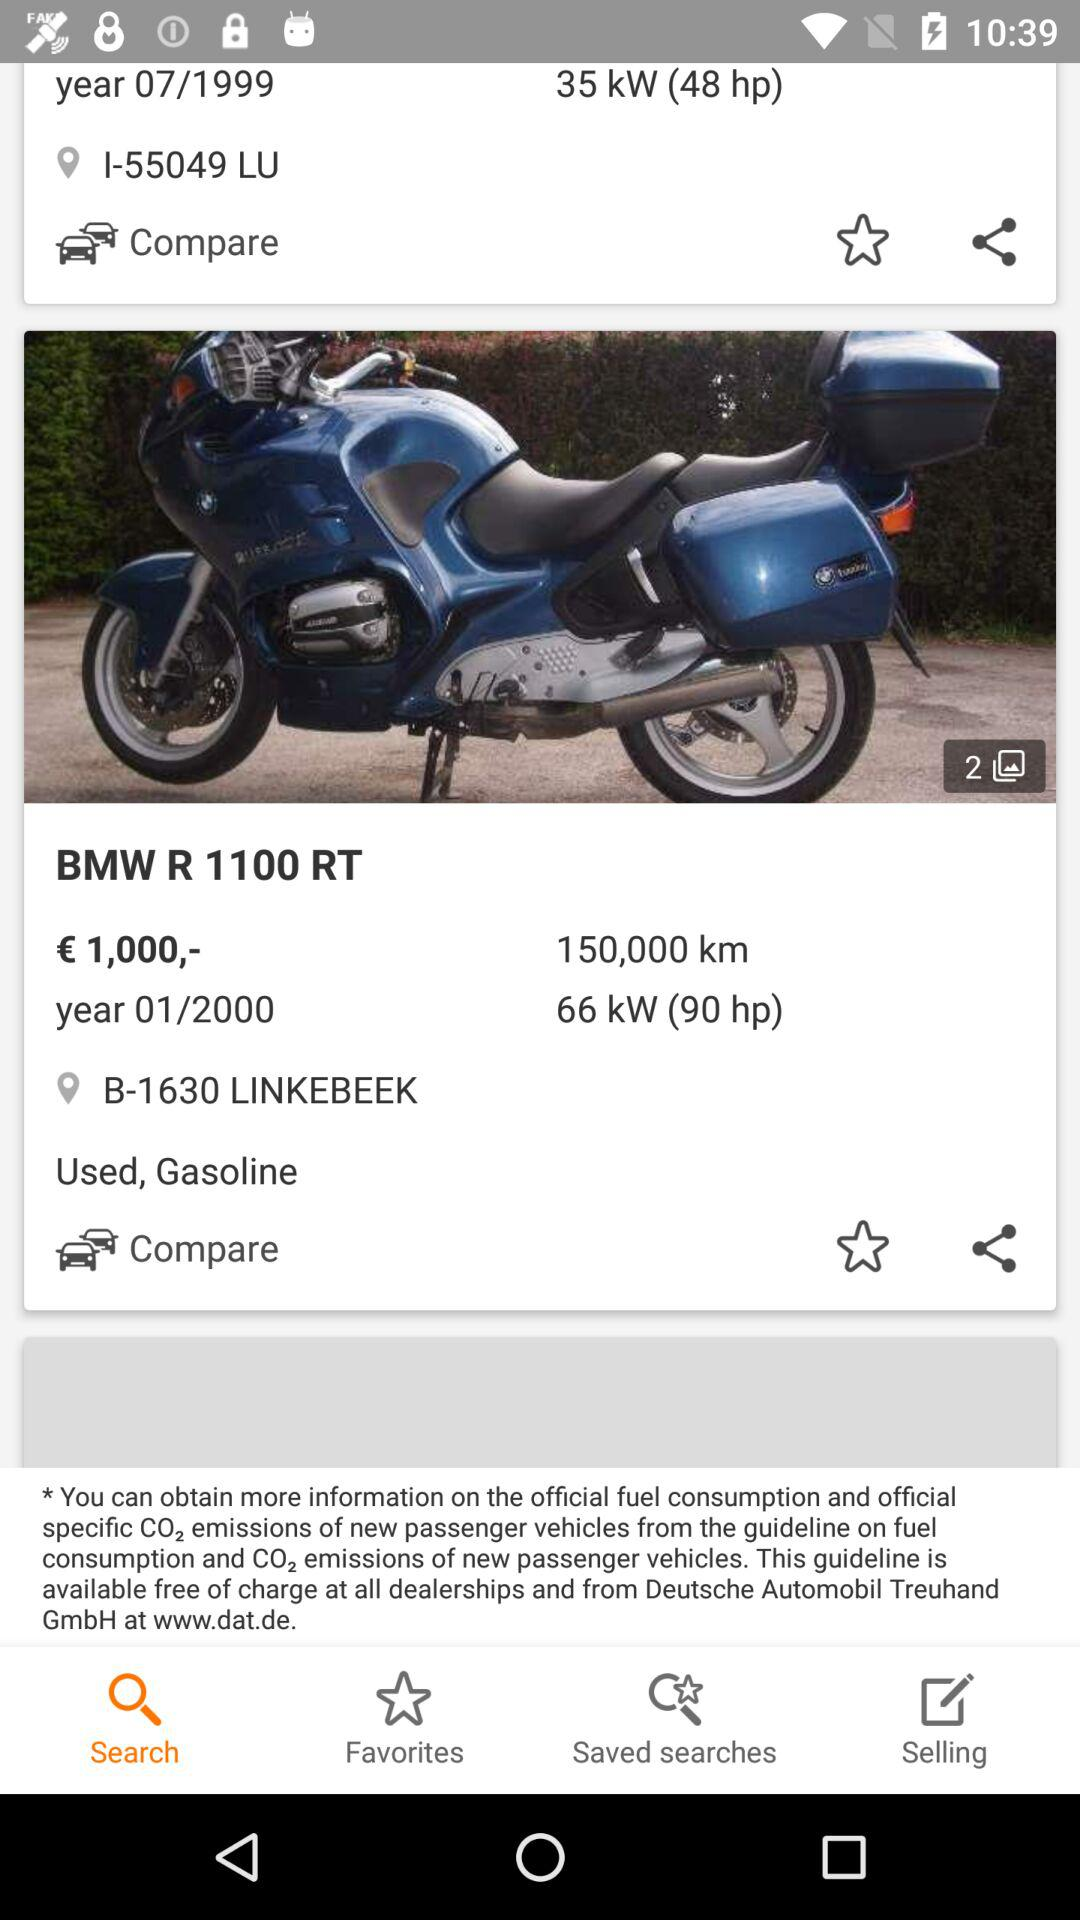What is the location? The locations are I-55049 LU and B-1630 Linkebeek. 